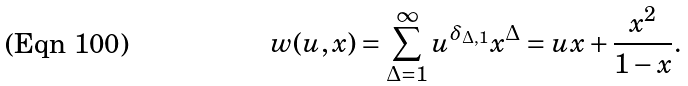Convert formula to latex. <formula><loc_0><loc_0><loc_500><loc_500>w ( u , x ) = \sum _ { \Delta = 1 } ^ { \infty } u ^ { \delta _ { \Delta , 1 } } x ^ { \Delta } = u x + \frac { x ^ { 2 } } { 1 - x } .</formula> 